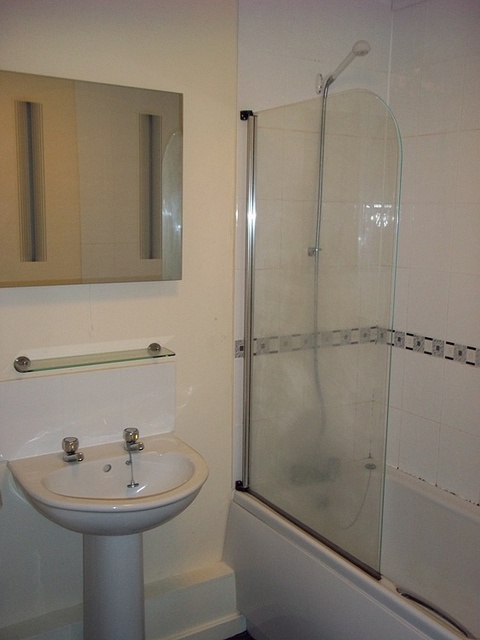Describe the objects in this image and their specific colors. I can see a sink in gray and darkgray tones in this image. 